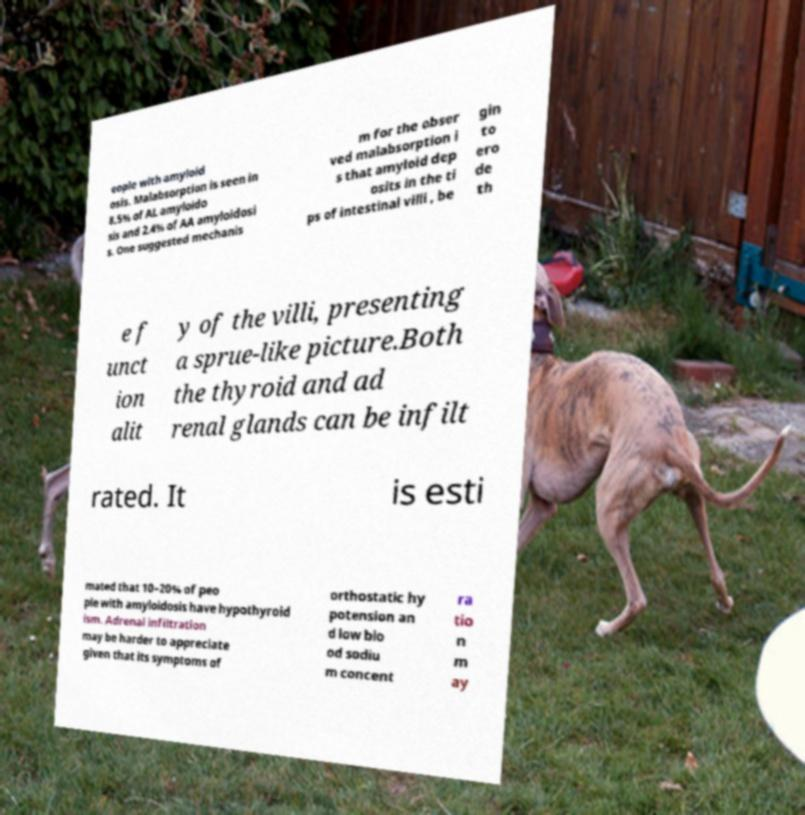What messages or text are displayed in this image? I need them in a readable, typed format. eople with amyloid osis. Malabsorption is seen in 8.5% of AL amyloido sis and 2.4% of AA amyloidosi s. One suggested mechanis m for the obser ved malabsorption i s that amyloid dep osits in the ti ps of intestinal villi , be gin to ero de th e f unct ion alit y of the villi, presenting a sprue-like picture.Both the thyroid and ad renal glands can be infilt rated. It is esti mated that 10–20% of peo ple with amyloidosis have hypothyroid ism. Adrenal infiltration may be harder to appreciate given that its symptoms of orthostatic hy potension an d low blo od sodiu m concent ra tio n m ay 